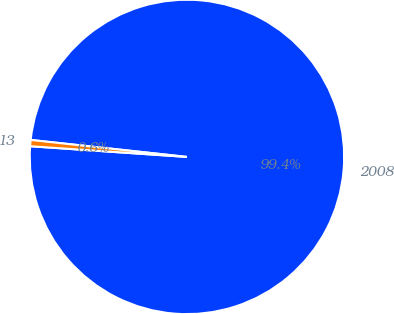Convert chart. <chart><loc_0><loc_0><loc_500><loc_500><pie_chart><fcel>2008<fcel>13<nl><fcel>99.36%<fcel>0.64%<nl></chart> 